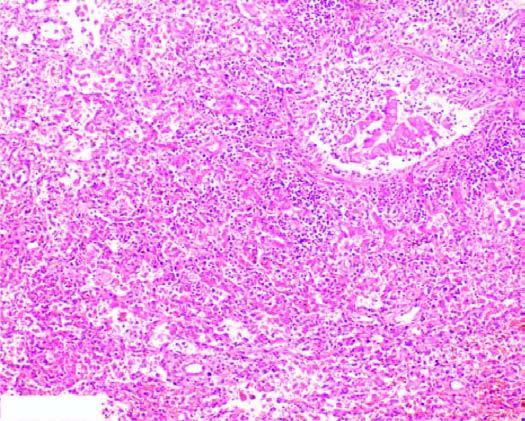re the alveolar septa thickened due to congested capillaries and neutrophilic infiltrate?
Answer the question using a single word or phrase. Yes 